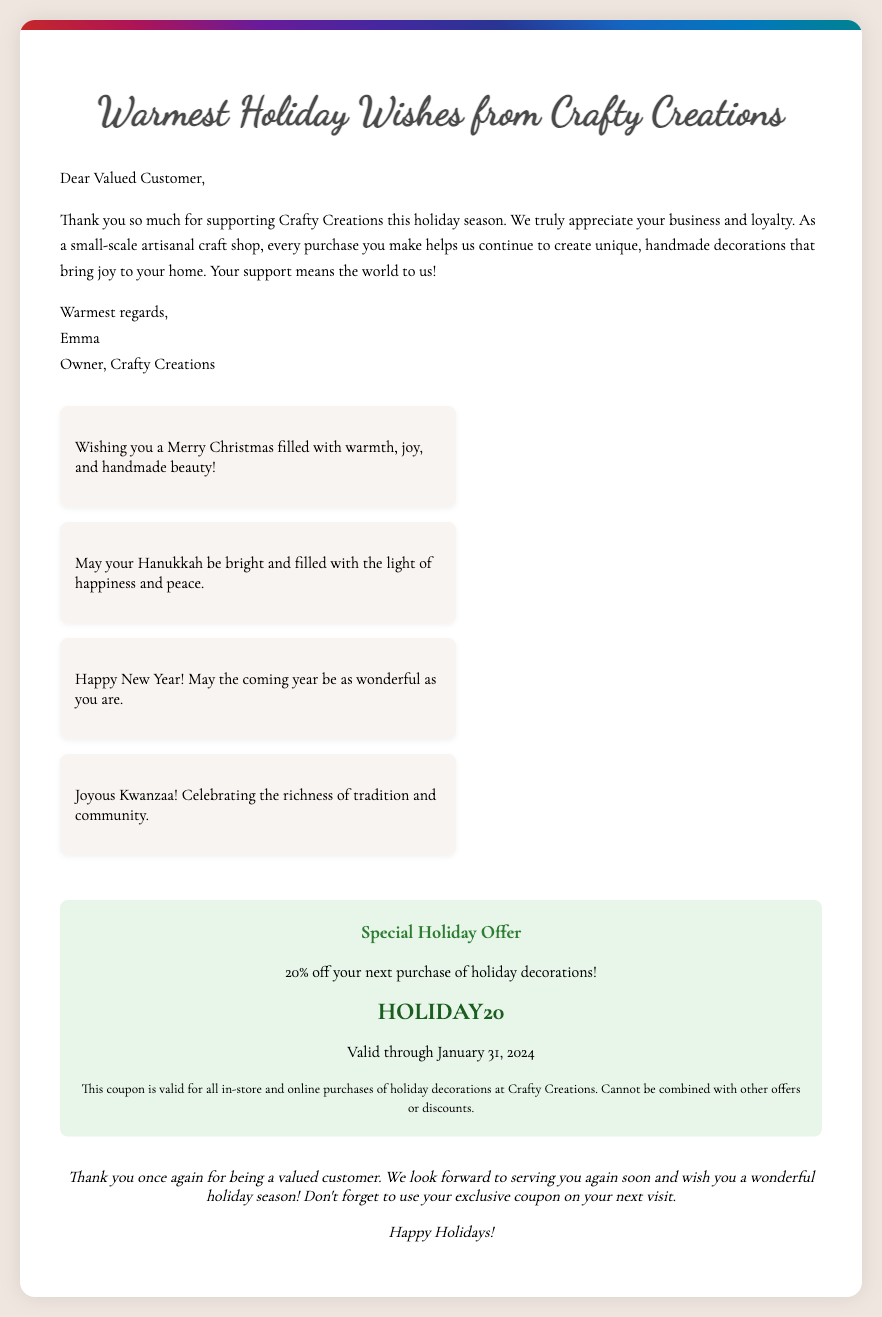What is the shop's name? The name of the shop featured in the document is mentioned prominently in the header.
Answer: Crafty Creations Who is the owner of the shop? The document includes a closing note where the owner introduces herself.
Answer: Emma What is the discount percentage offered in the coupon? The coupon section of the document clearly states the percentage.
Answer: 20% Until when is the coupon valid? The validity of the coupon is specified in the coupon section of the document.
Answer: January 31, 2024 What holiday is specifically mentioned for wishes related to joy and beauty? One of the messages highlights a specific holiday and its associated sentiments.
Answer: Christmas What is one of the themes celebrated in Kwanzaa according to the document? The document mentions themes related to Kwanzaa in one of the messages.
Answer: Tradition What type of message is included for Hanukkah? The document has a specific sentence themed around another holiday.
Answer: Brightness and happiness Is the coupon applicable for online purchases? The terms of the coupon clarify where it can be used.
Answer: Yes 